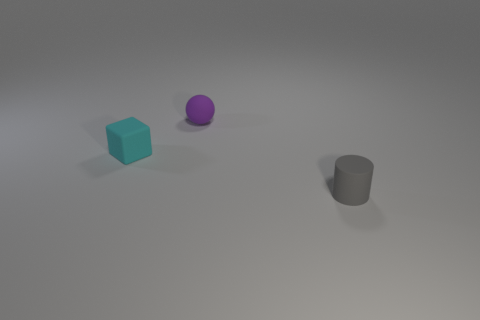Add 1 purple rubber spheres. How many objects exist? 4 Subtract all cylinders. How many objects are left? 2 Subtract all large red metallic spheres. Subtract all purple matte spheres. How many objects are left? 2 Add 2 tiny purple balls. How many tiny purple balls are left? 3 Add 1 big brown matte cylinders. How many big brown matte cylinders exist? 1 Subtract 0 yellow cylinders. How many objects are left? 3 Subtract 1 blocks. How many blocks are left? 0 Subtract all brown spheres. Subtract all cyan cylinders. How many spheres are left? 1 